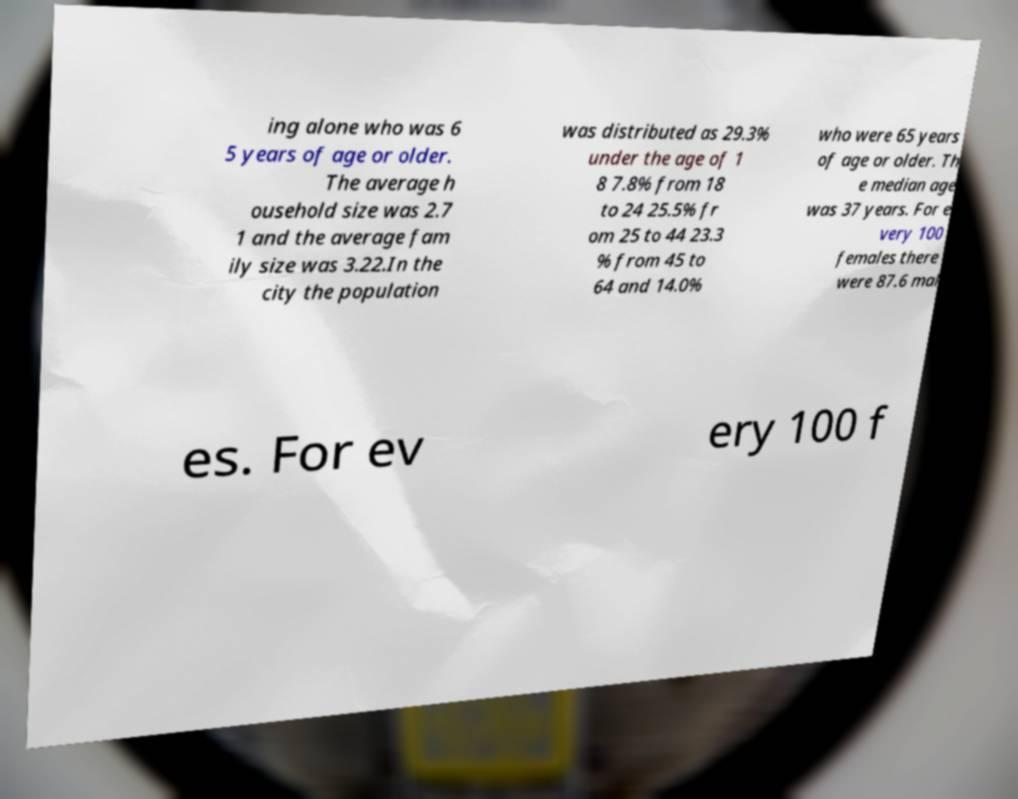Please identify and transcribe the text found in this image. ing alone who was 6 5 years of age or older. The average h ousehold size was 2.7 1 and the average fam ily size was 3.22.In the city the population was distributed as 29.3% under the age of 1 8 7.8% from 18 to 24 25.5% fr om 25 to 44 23.3 % from 45 to 64 and 14.0% who were 65 years of age or older. Th e median age was 37 years. For e very 100 females there were 87.6 mal es. For ev ery 100 f 